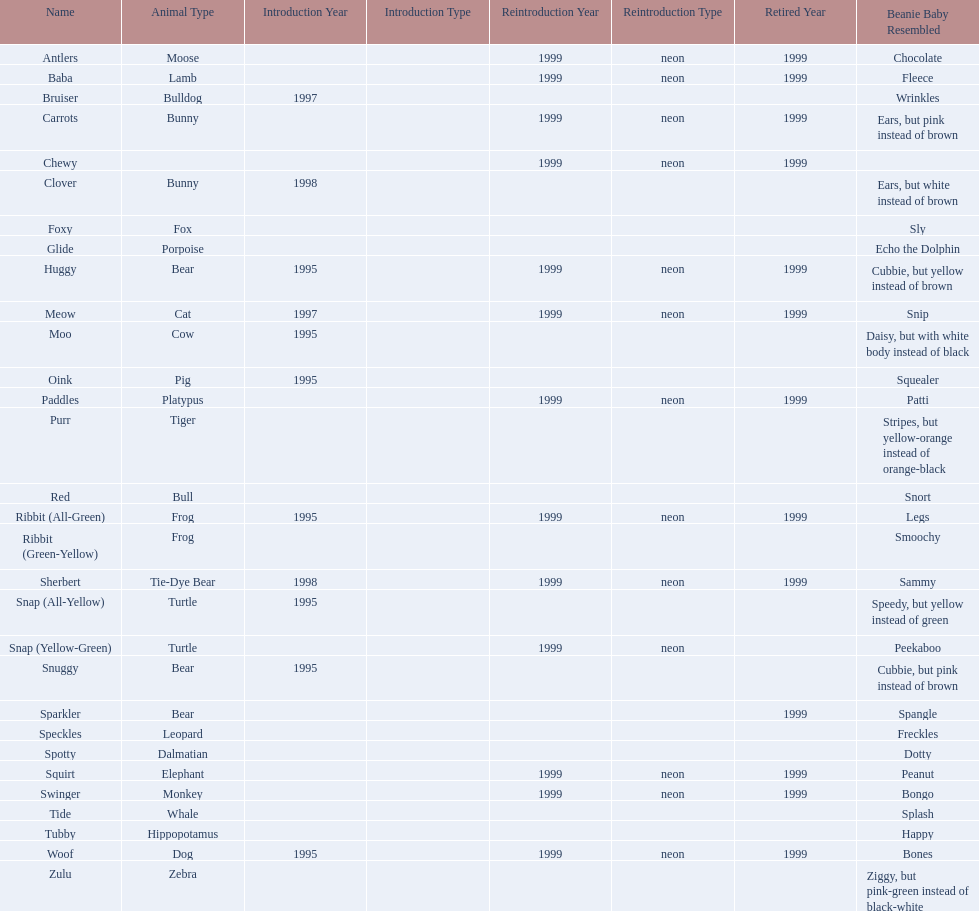In what year were the first pillow pals introduced? 1995. 